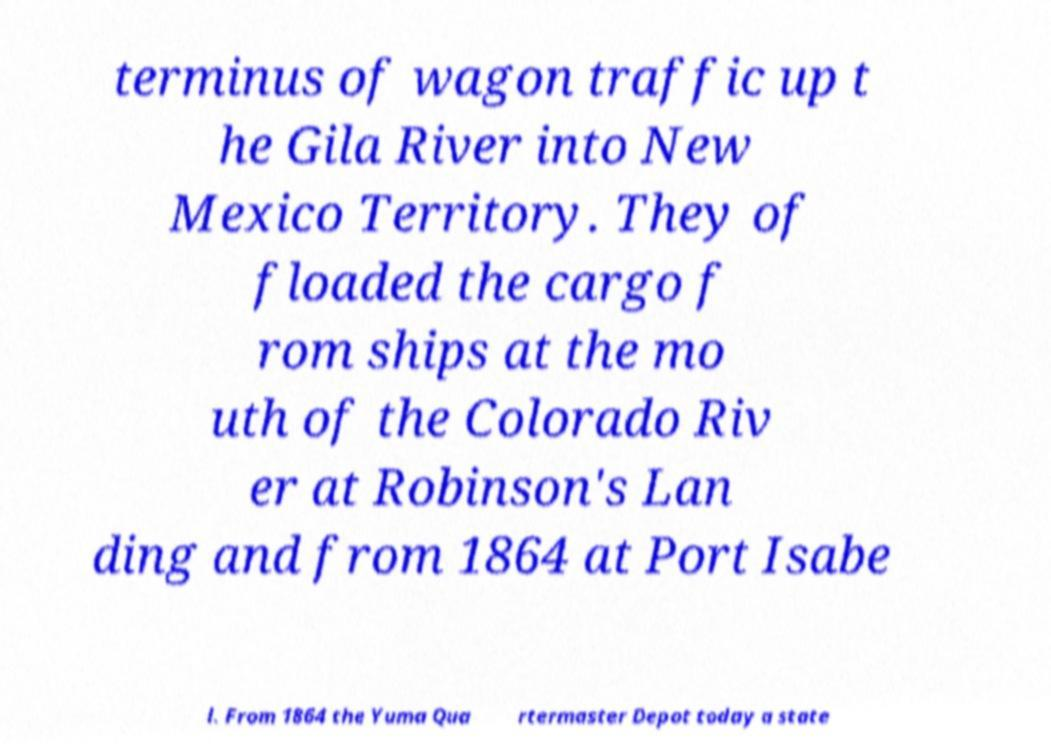Could you extract and type out the text from this image? terminus of wagon traffic up t he Gila River into New Mexico Territory. They of floaded the cargo f rom ships at the mo uth of the Colorado Riv er at Robinson's Lan ding and from 1864 at Port Isabe l. From 1864 the Yuma Qua rtermaster Depot today a state 